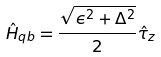<formula> <loc_0><loc_0><loc_500><loc_500>\hat { H } _ { q b } = \frac { \sqrt { \epsilon ^ { 2 } + \Delta ^ { 2 } } } { 2 } \hat { \tau } _ { z }</formula> 